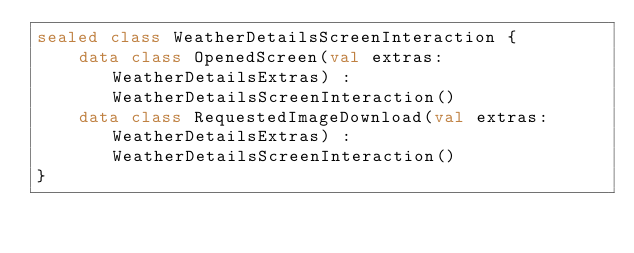Convert code to text. <code><loc_0><loc_0><loc_500><loc_500><_Kotlin_>sealed class WeatherDetailsScreenInteraction {
    data class OpenedScreen(val extras: WeatherDetailsExtras) : WeatherDetailsScreenInteraction()
    data class RequestedImageDownload(val extras: WeatherDetailsExtras) : WeatherDetailsScreenInteraction()
}
</code> 